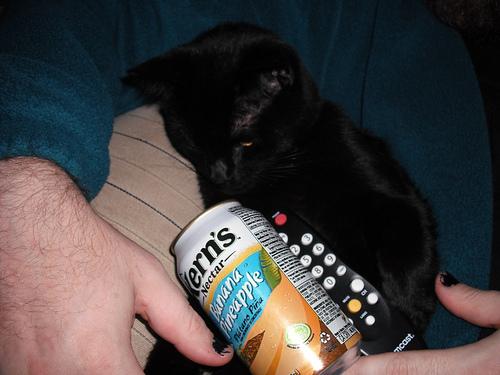What type of drink is in the can?
Keep it brief. Banana pineapple. Which item is in the middle?
Answer briefly. Remote. What is the cat sitting on?
Be succinct. Lap. Is the cat asleep?
Short answer required. No. 